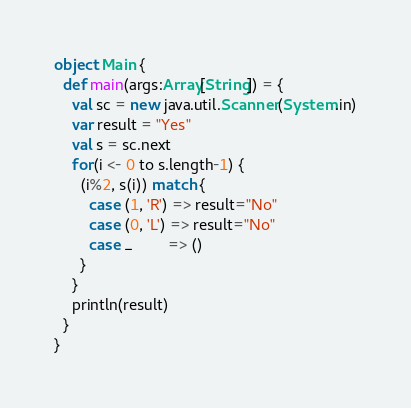<code> <loc_0><loc_0><loc_500><loc_500><_Scala_>object Main {
  def main(args:Array[String]) = {
    val sc = new java.util.Scanner(System.in)
    var result = "Yes"
    val s = sc.next
    for(i <- 0 to s.length-1) {
      (i%2, s(i)) match {
        case (1, 'R') => result="No"
        case (0, 'L') => result="No"
        case _        => ()
      }
    }
    println(result)
  }
}
</code> 